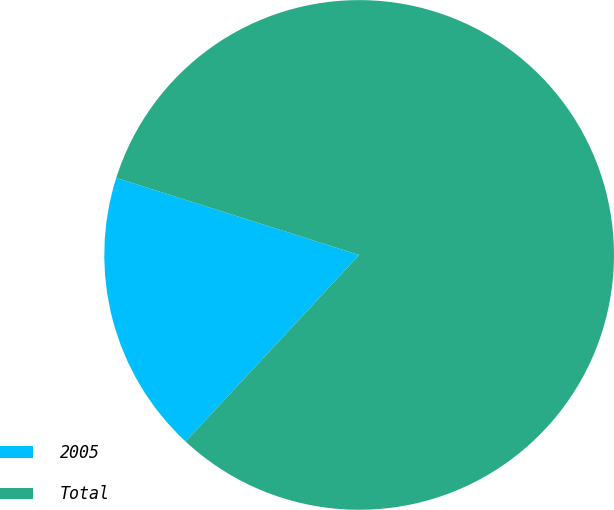Convert chart to OTSL. <chart><loc_0><loc_0><loc_500><loc_500><pie_chart><fcel>2005<fcel>Total<nl><fcel>17.97%<fcel>82.03%<nl></chart> 